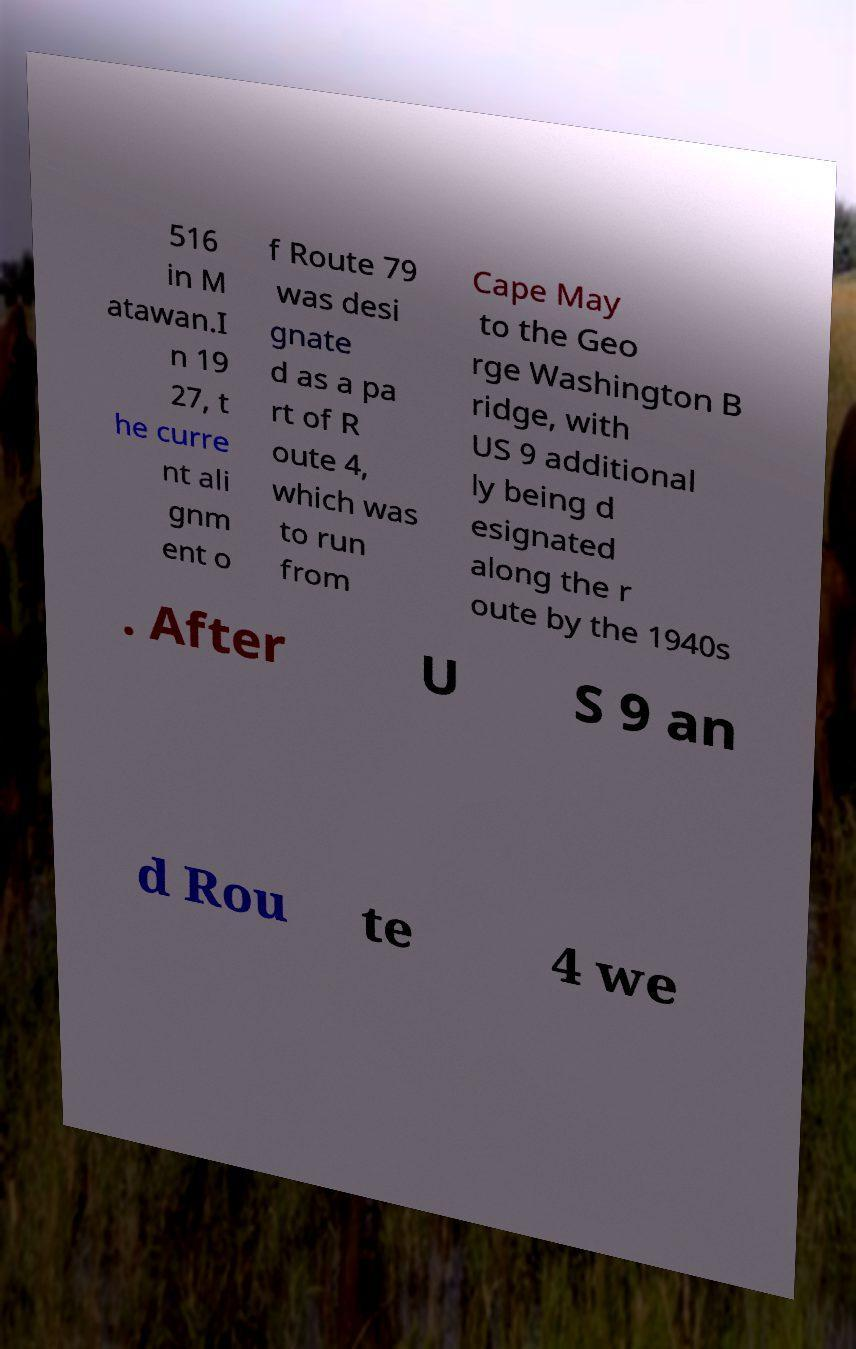I need the written content from this picture converted into text. Can you do that? 516 in M atawan.I n 19 27, t he curre nt ali gnm ent o f Route 79 was desi gnate d as a pa rt of R oute 4, which was to run from Cape May to the Geo rge Washington B ridge, with US 9 additional ly being d esignated along the r oute by the 1940s . After U S 9 an d Rou te 4 we 